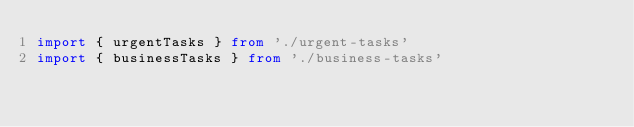<code> <loc_0><loc_0><loc_500><loc_500><_TypeScript_>import { urgentTasks } from './urgent-tasks'
import { businessTasks } from './business-tasks'</code> 